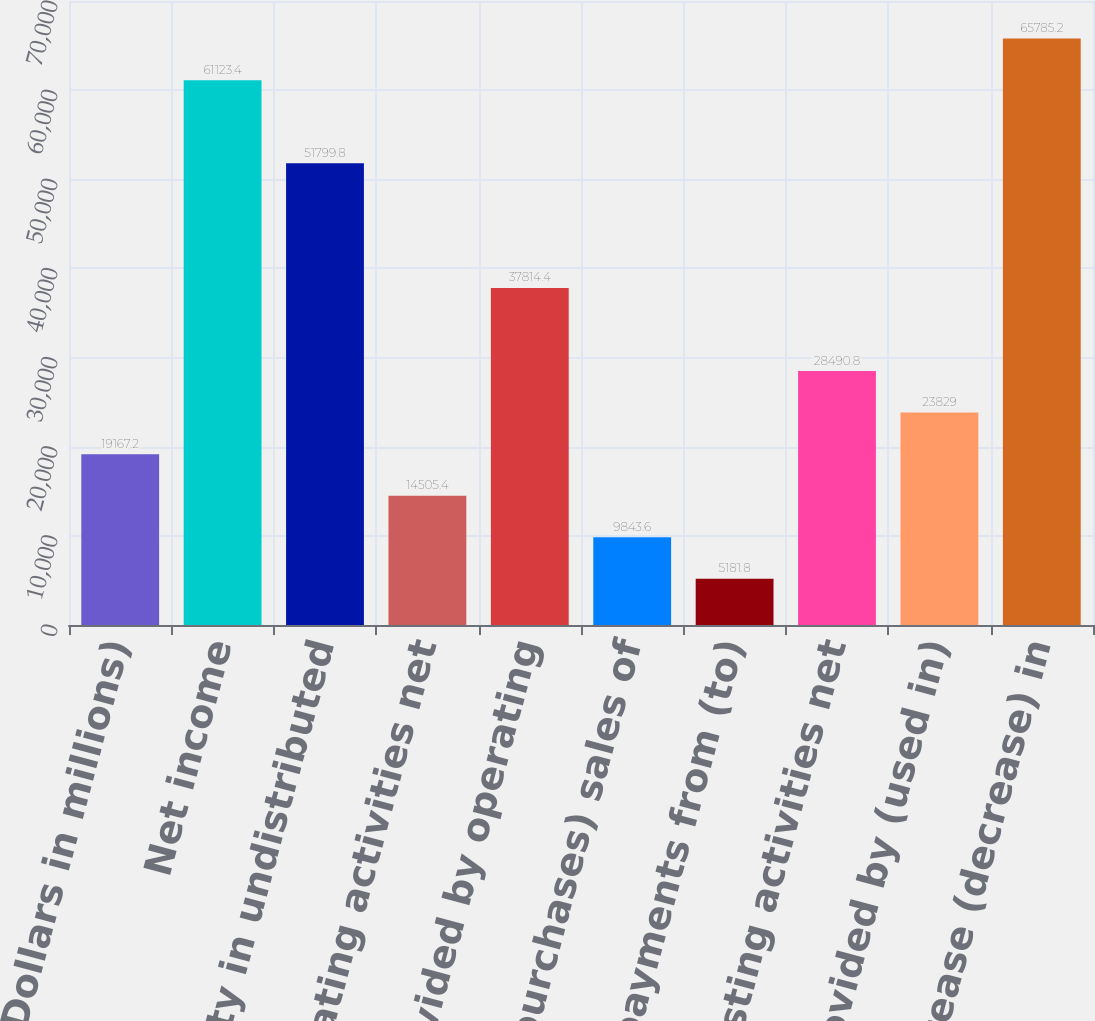Convert chart to OTSL. <chart><loc_0><loc_0><loc_500><loc_500><bar_chart><fcel>(Dollars in millions)<fcel>Net income<fcel>Equity in undistributed<fcel>Other operating activities net<fcel>Net cash provided by operating<fcel>Net (purchases) sales of<fcel>Net payments from (to)<fcel>Other investing activities net<fcel>Net cash provided by (used in)<fcel>Net increase (decrease) in<nl><fcel>19167.2<fcel>61123.4<fcel>51799.8<fcel>14505.4<fcel>37814.4<fcel>9843.6<fcel>5181.8<fcel>28490.8<fcel>23829<fcel>65785.2<nl></chart> 